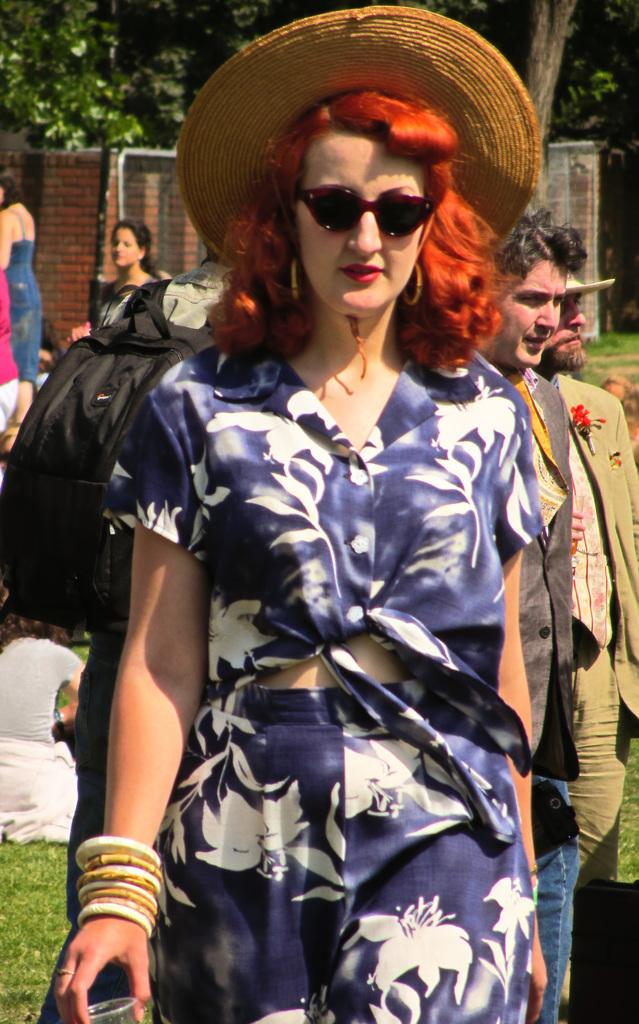How many people are in the image? There are people in the image, but the exact number is not specified. What is the lady holding in the image? The lady is holding a glass in the image. What accessory is worn by one of the people in the image? One person is wearing a backpack in the image. What type of natural environment can be seen in the image? Trees are visible in the image, indicating a natural environment. What type of structure is visible in the image? There is a wall visible in the image, suggesting a man-made structure. What type of tail can be seen on the skirt in the image? There is no skirt or tail present in the image. What is the plot of the story being told in the image? The image does not depict a story or plot; it is a static representation of people, objects, and structures. 